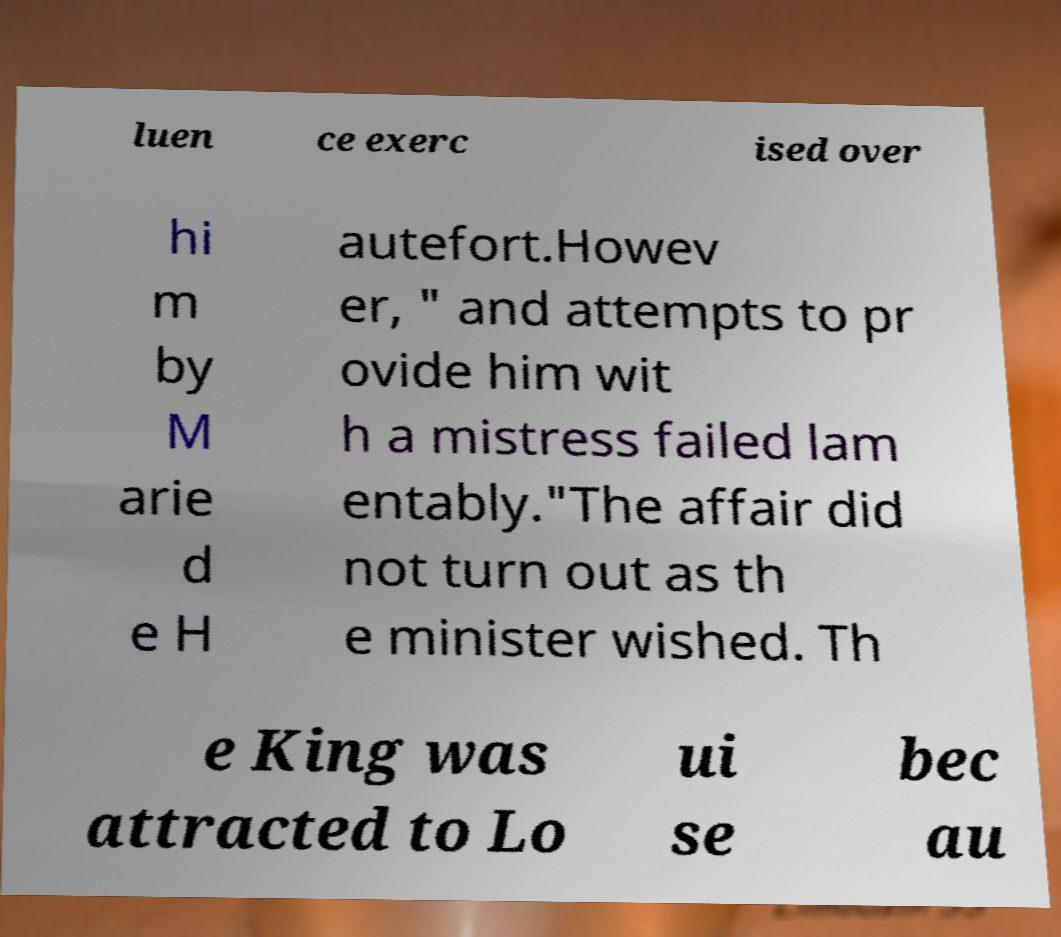For documentation purposes, I need the text within this image transcribed. Could you provide that? luen ce exerc ised over hi m by M arie d e H autefort.Howev er, " and attempts to pr ovide him wit h a mistress failed lam entably."The affair did not turn out as th e minister wished. Th e King was attracted to Lo ui se bec au 